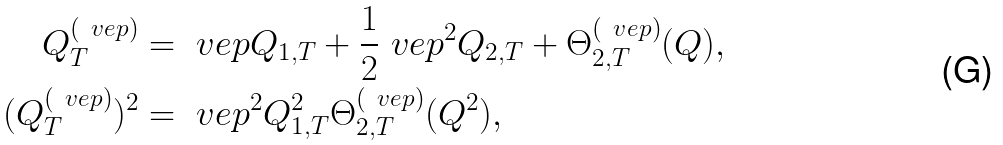<formula> <loc_0><loc_0><loc_500><loc_500>Q _ { T } ^ { ( \ v e p ) } & = \ v e p Q _ { 1 , T } + \frac { 1 } { 2 } \ v e p ^ { 2 } Q _ { 2 , T } + \Theta ^ { ( \ v e p ) } _ { 2 , T } ( Q ) , \\ ( Q _ { T } ^ { ( \ v e p ) } ) ^ { 2 } & = \ v e p ^ { 2 } Q ^ { 2 } _ { 1 , T } \Theta ^ { ( \ v e p ) } _ { 2 , T } ( Q ^ { 2 } ) ,</formula> 